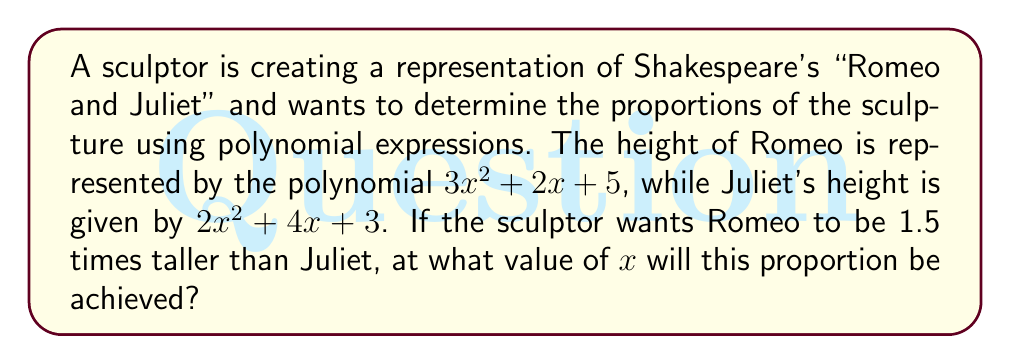Provide a solution to this math problem. To solve this problem, we need to follow these steps:

1) Let's express the condition mathematically:
   Romeo's height = 1.5 × Juliet's height
   
   $3x^2 + 2x + 5 = 1.5(2x^2 + 4x + 3)$

2) Expand the right side of the equation:
   $3x^2 + 2x + 5 = 3x^2 + 6x + 4.5$

3) Subtract the left side from both sides:
   $0 = 3x^2 + 6x + 4.5 - (3x^2 + 2x + 5)$
   $0 = 4x - 0.5$

4) Add 0.5 to both sides:
   $0.5 = 4x$

5) Divide both sides by 4:
   $\frac{1}{8} = x$

Therefore, the proportion will be achieved when $x = \frac{1}{8}$.
Answer: $x = \frac{1}{8}$ 